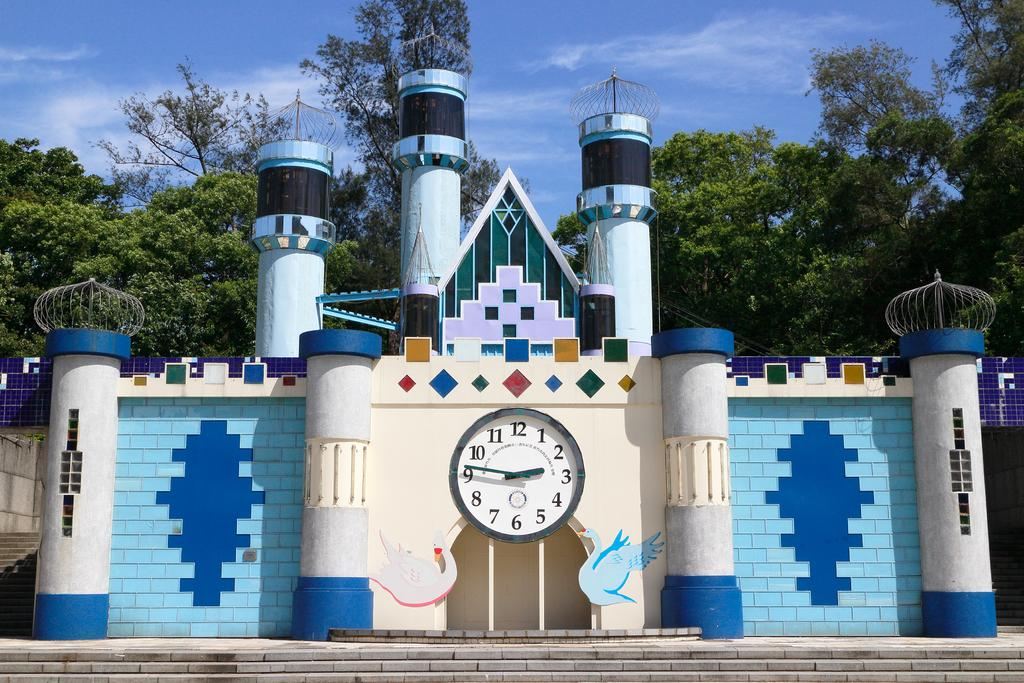<image>
Present a compact description of the photo's key features. Castle image that is blue and white all around it with a time saying 2:47. 